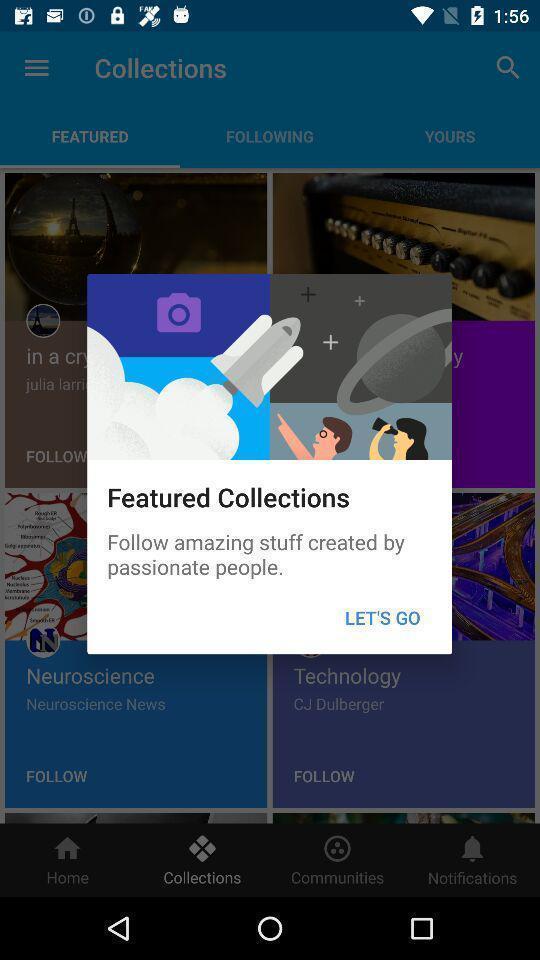Explain what's happening in this screen capture. Pop-up to view the featured collections. 